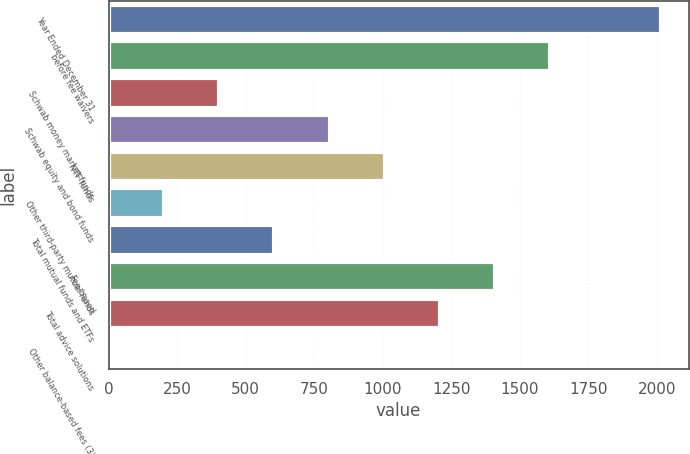<chart> <loc_0><loc_0><loc_500><loc_500><bar_chart><fcel>Year Ended December 31<fcel>before fee waivers<fcel>Schwab money market funds<fcel>Schwab equity and bond funds<fcel>NTF funds<fcel>Other third-party mutual funds<fcel>Total mutual funds and ETFs<fcel>Fee-based<fcel>Total advice solutions<fcel>Other balance-based fees (3)<nl><fcel>2015<fcel>1611.99<fcel>403.05<fcel>806.03<fcel>1007.52<fcel>201.56<fcel>604.54<fcel>1410.5<fcel>1209.01<fcel>0.07<nl></chart> 